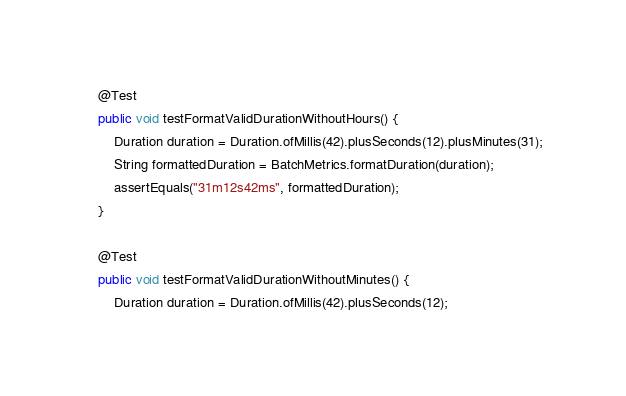<code> <loc_0><loc_0><loc_500><loc_500><_Java_>	@Test
	public void testFormatValidDurationWithoutHours() {
		Duration duration = Duration.ofMillis(42).plusSeconds(12).plusMinutes(31);
		String formattedDuration = BatchMetrics.formatDuration(duration);
		assertEquals("31m12s42ms", formattedDuration);
	}

	@Test
	public void testFormatValidDurationWithoutMinutes() {
		Duration duration = Duration.ofMillis(42).plusSeconds(12);</code> 